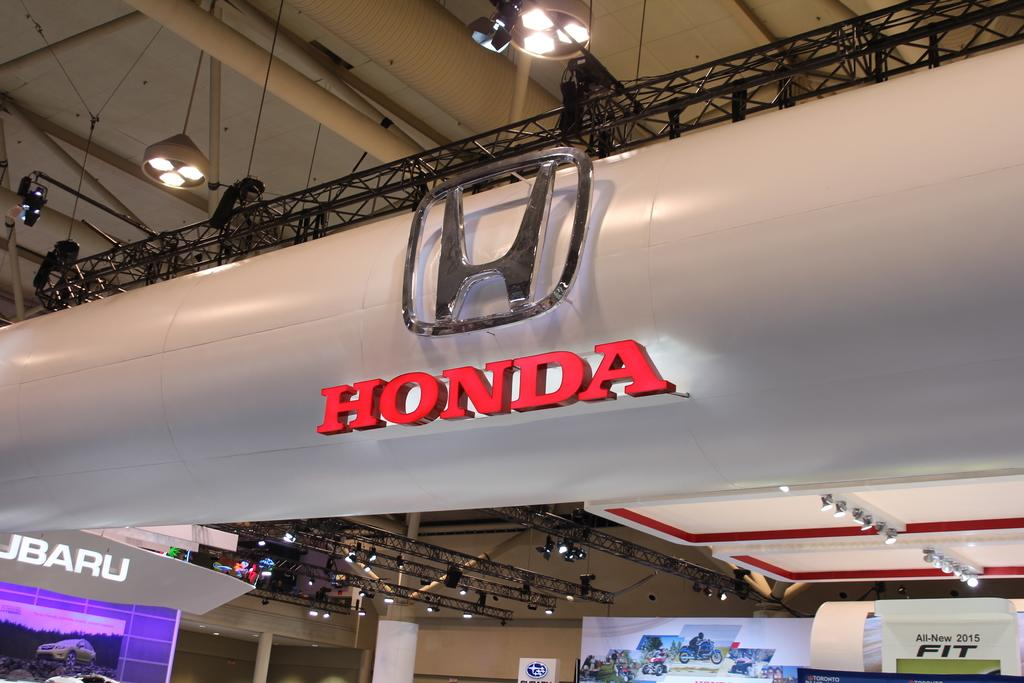Provide a one-sentence caption for the provided image. A large Honda sign hangs above a Subaru sign. 